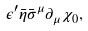<formula> <loc_0><loc_0><loc_500><loc_500>\epsilon ^ { \prime } \bar { \eta } \bar { \sigma } ^ { \mu } \partial _ { \mu } \chi _ { 0 } ,</formula> 